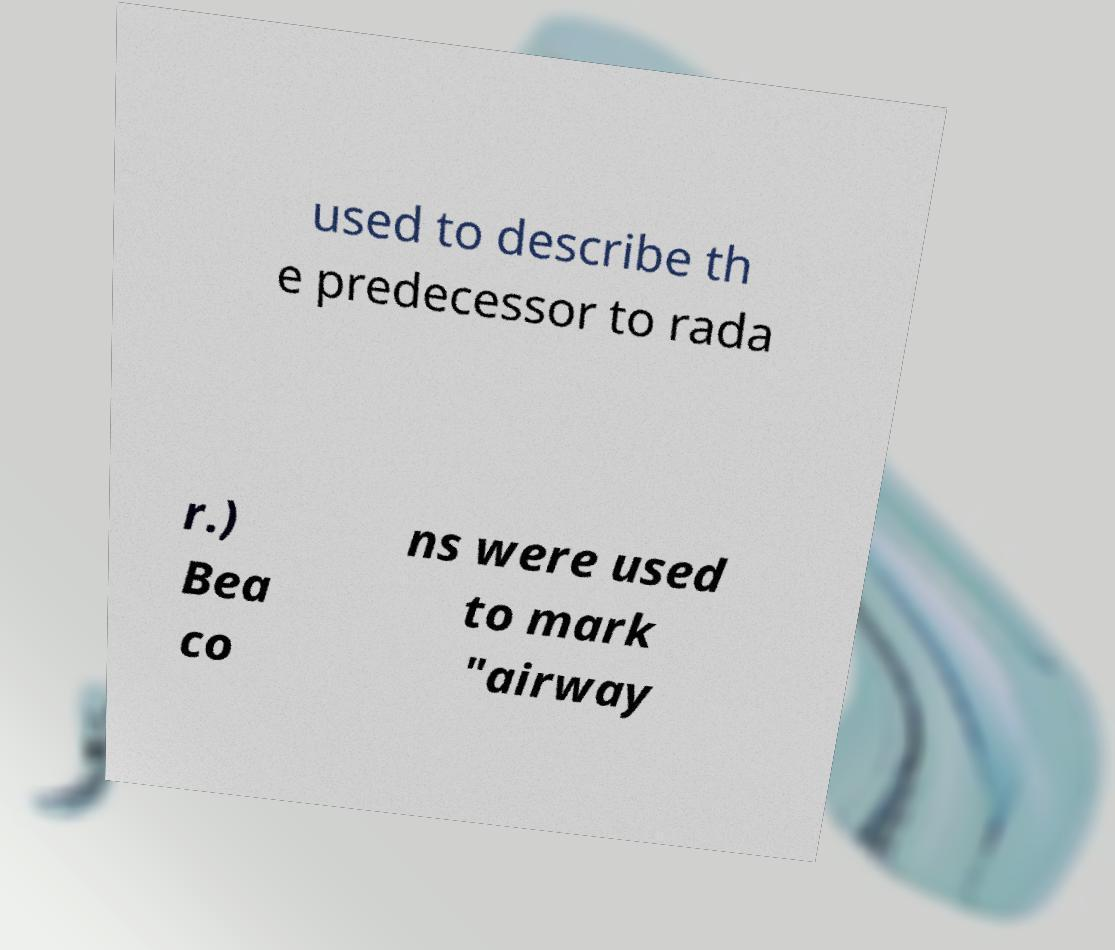There's text embedded in this image that I need extracted. Can you transcribe it verbatim? used to describe th e predecessor to rada r.) Bea co ns were used to mark "airway 